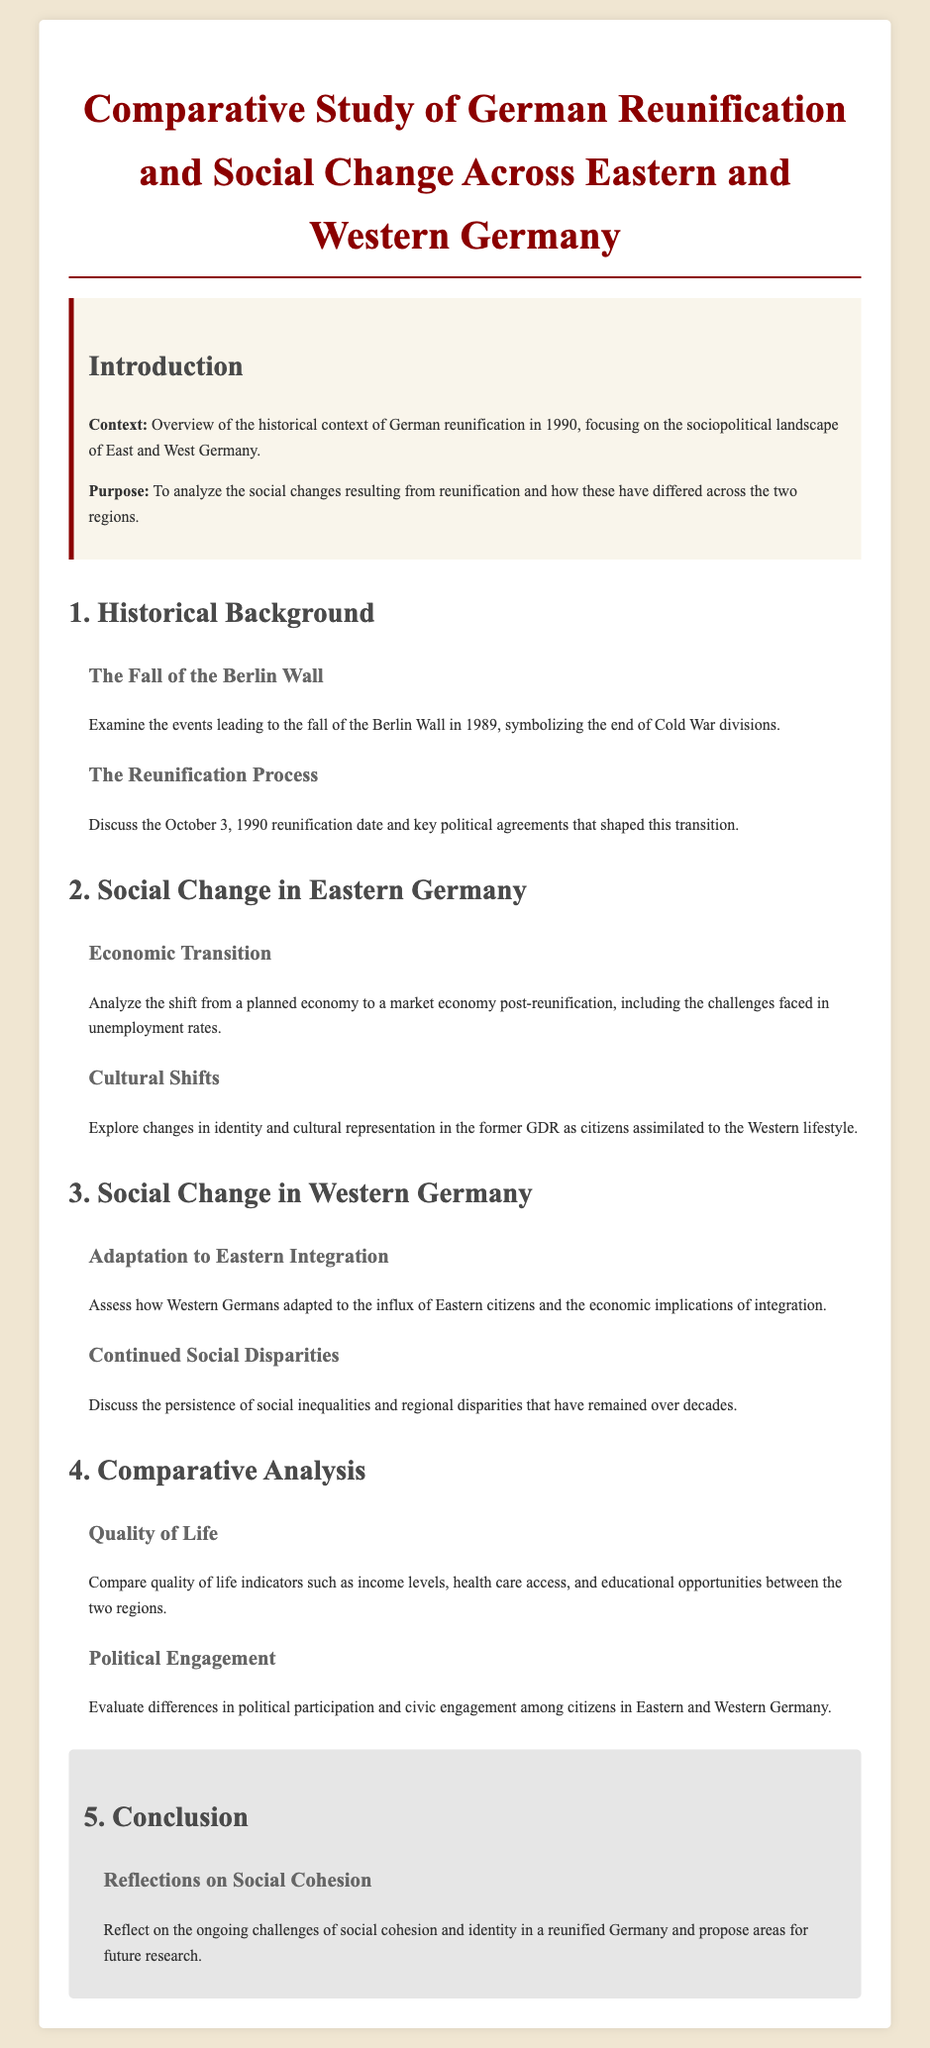What is the title of the study? The title is explicitly stated at the beginning of the document, focusing on German reunification and social change.
Answer: Comparative Study of German Reunification and Social Change Across Eastern and Western Germany When did the reunification take place? The date of reunification is mentioned along with its significance in the document.
Answer: October 3, 1990 What event symbolized the end of Cold War divisions? This event is specified in the section discussing the historical background of reunification.
Answer: The Fall of the Berlin Wall Which region faced challenges in unemployment rates post-reunification? This information is found in the section on social change in Eastern Germany, discussing economic transition.
Answer: Eastern Germany What aspect of social change is assessed in Western Germany? The document explicitly mentions this focus under its relevant section discussing the Western region's experience.
Answer: Adaptation to Eastern Integration What are the two regions compared in terms of quality of life? This is mentioned in the comparative analysis section of the document.
Answer: Eastern and Western Germany What is a key theme proposed for future research? The conclusion section highlights this as an area for further inquiry in a reunified Germany.
Answer: Social Cohesion What does the introduction provide an overview of? The introduction sets the stage for the study by discussing its historical context.
Answer: Historical context of German reunification What does the cultural shift in Eastern Germany refer to? This is specifically addressed in the section concerning social change in Eastern Germany.
Answer: Changes in identity and cultural representation 